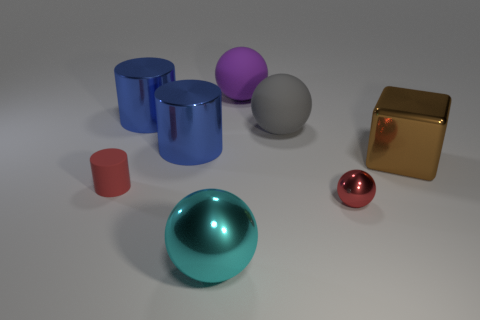What material is the other object that is the same color as the tiny matte thing?
Give a very brief answer. Metal. What number of tiny shiny spheres are on the left side of the small rubber cylinder?
Make the answer very short. 0. Is the purple object made of the same material as the object that is on the right side of the small metal object?
Ensure brevity in your answer.  No. Is there any other thing that has the same shape as the gray thing?
Provide a succinct answer. Yes. Is the cyan ball made of the same material as the small red ball?
Provide a short and direct response. Yes. There is a big sphere left of the big purple rubber thing; is there a big purple rubber sphere left of it?
Your response must be concise. No. How many big spheres are both behind the red sphere and in front of the purple sphere?
Offer a terse response. 1. There is a big thing in front of the red metal thing; what shape is it?
Your response must be concise. Sphere. What number of gray spheres are the same size as the brown block?
Ensure brevity in your answer.  1. Does the big sphere that is in front of the big gray thing have the same color as the tiny cylinder?
Your response must be concise. No. 